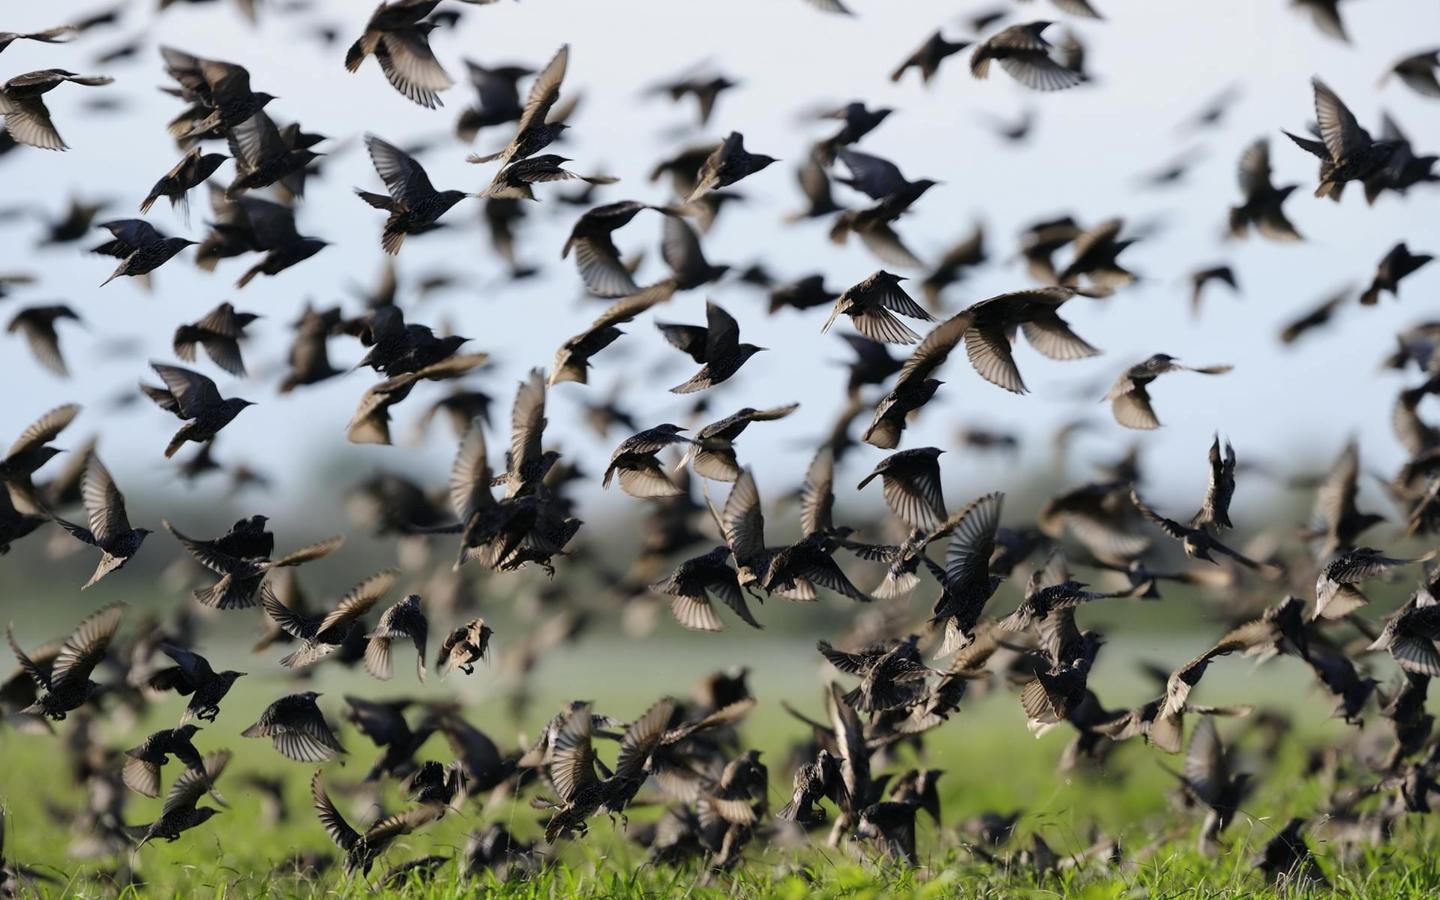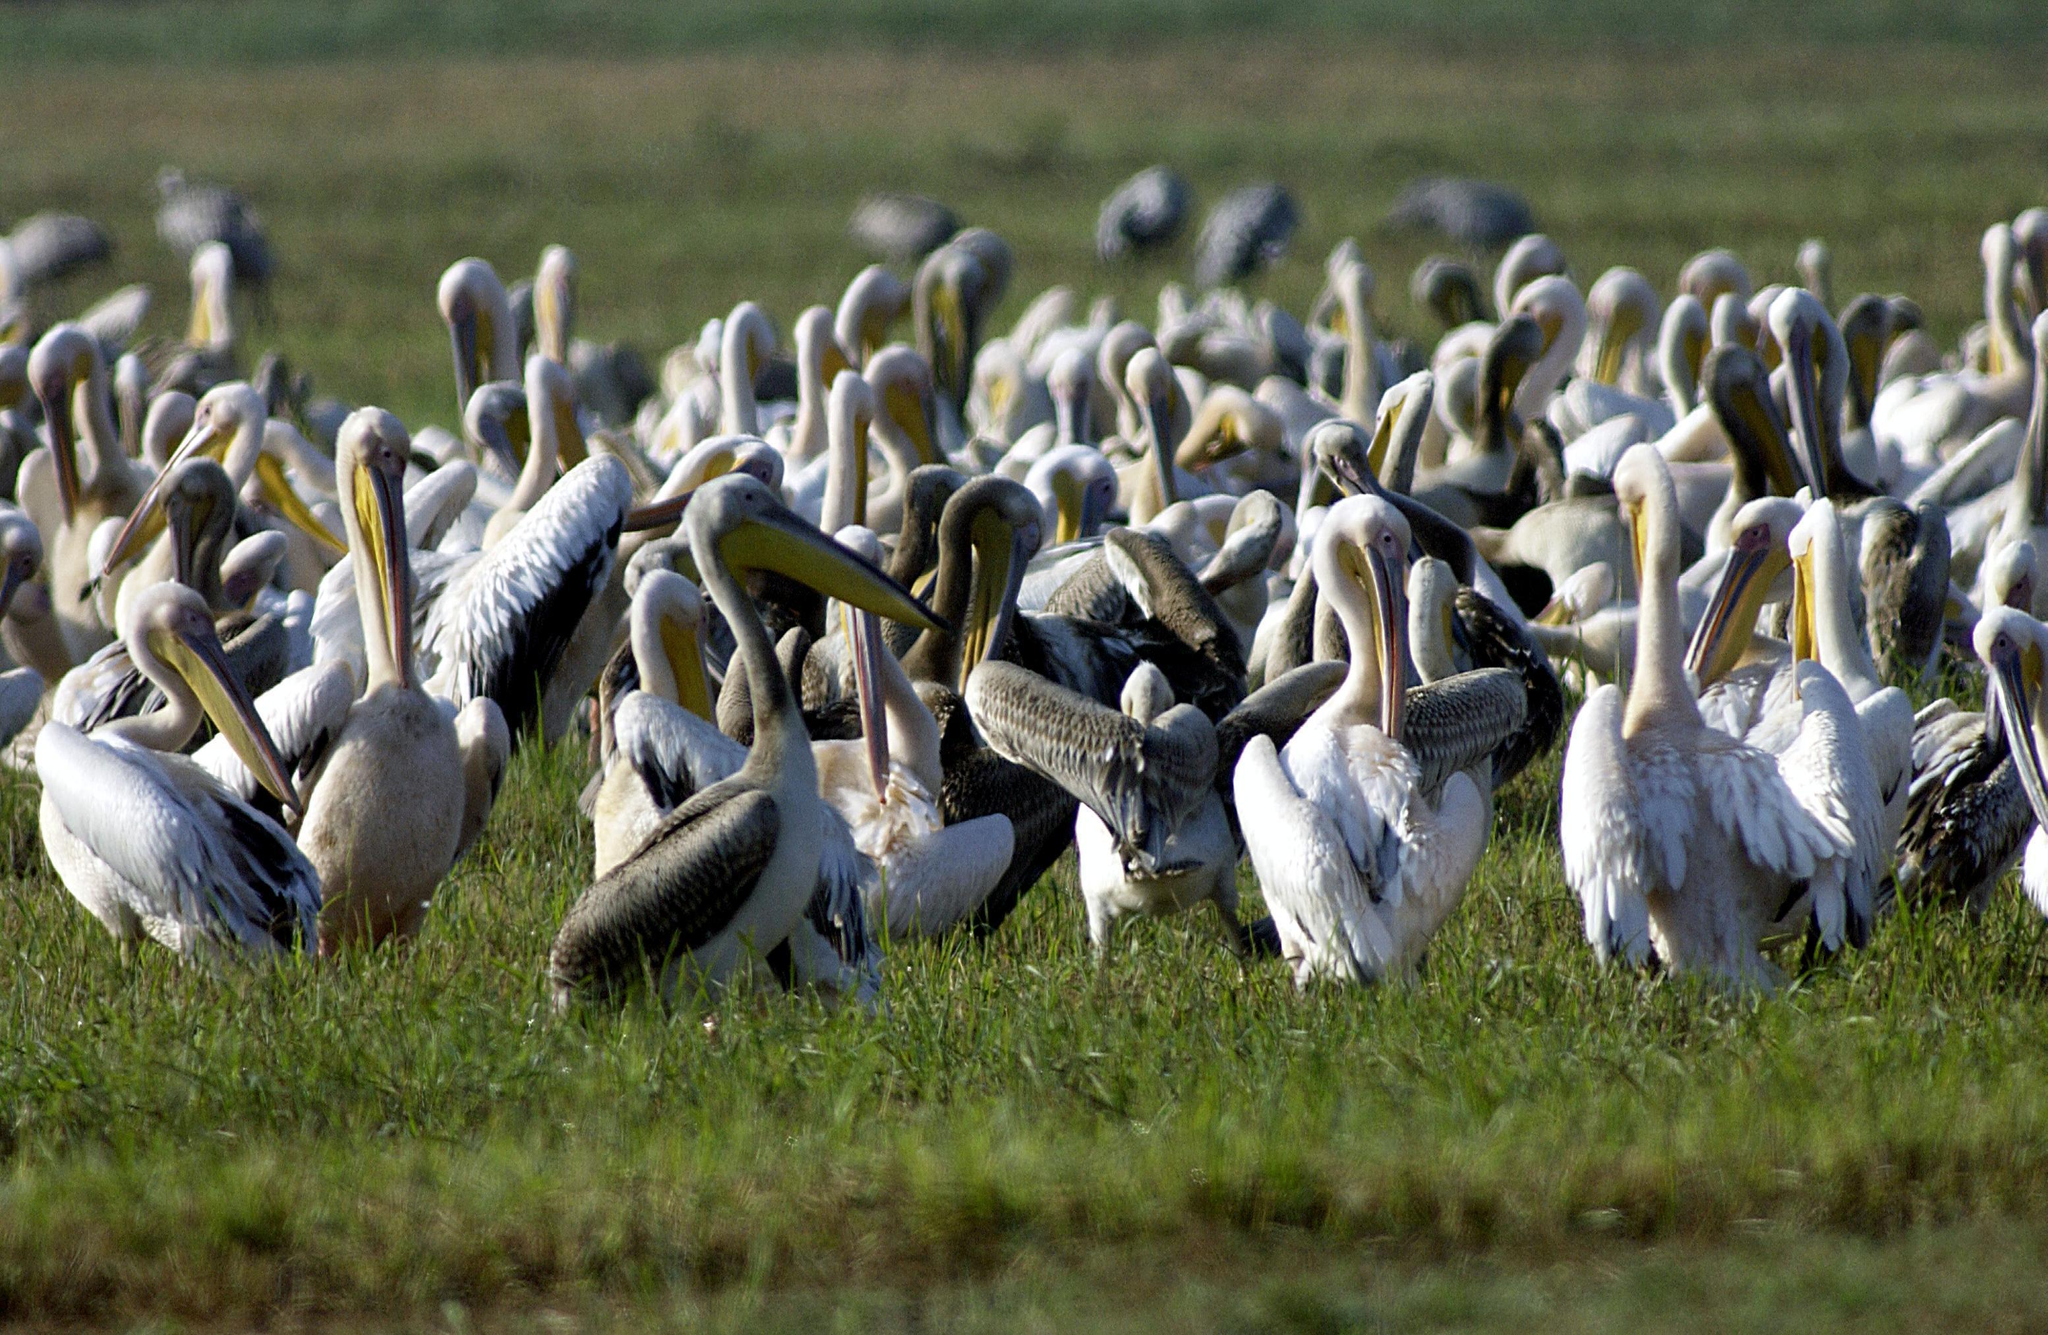The first image is the image on the left, the second image is the image on the right. For the images displayed, is the sentence "All of the birds are in or near the water." factually correct? Answer yes or no. No. 